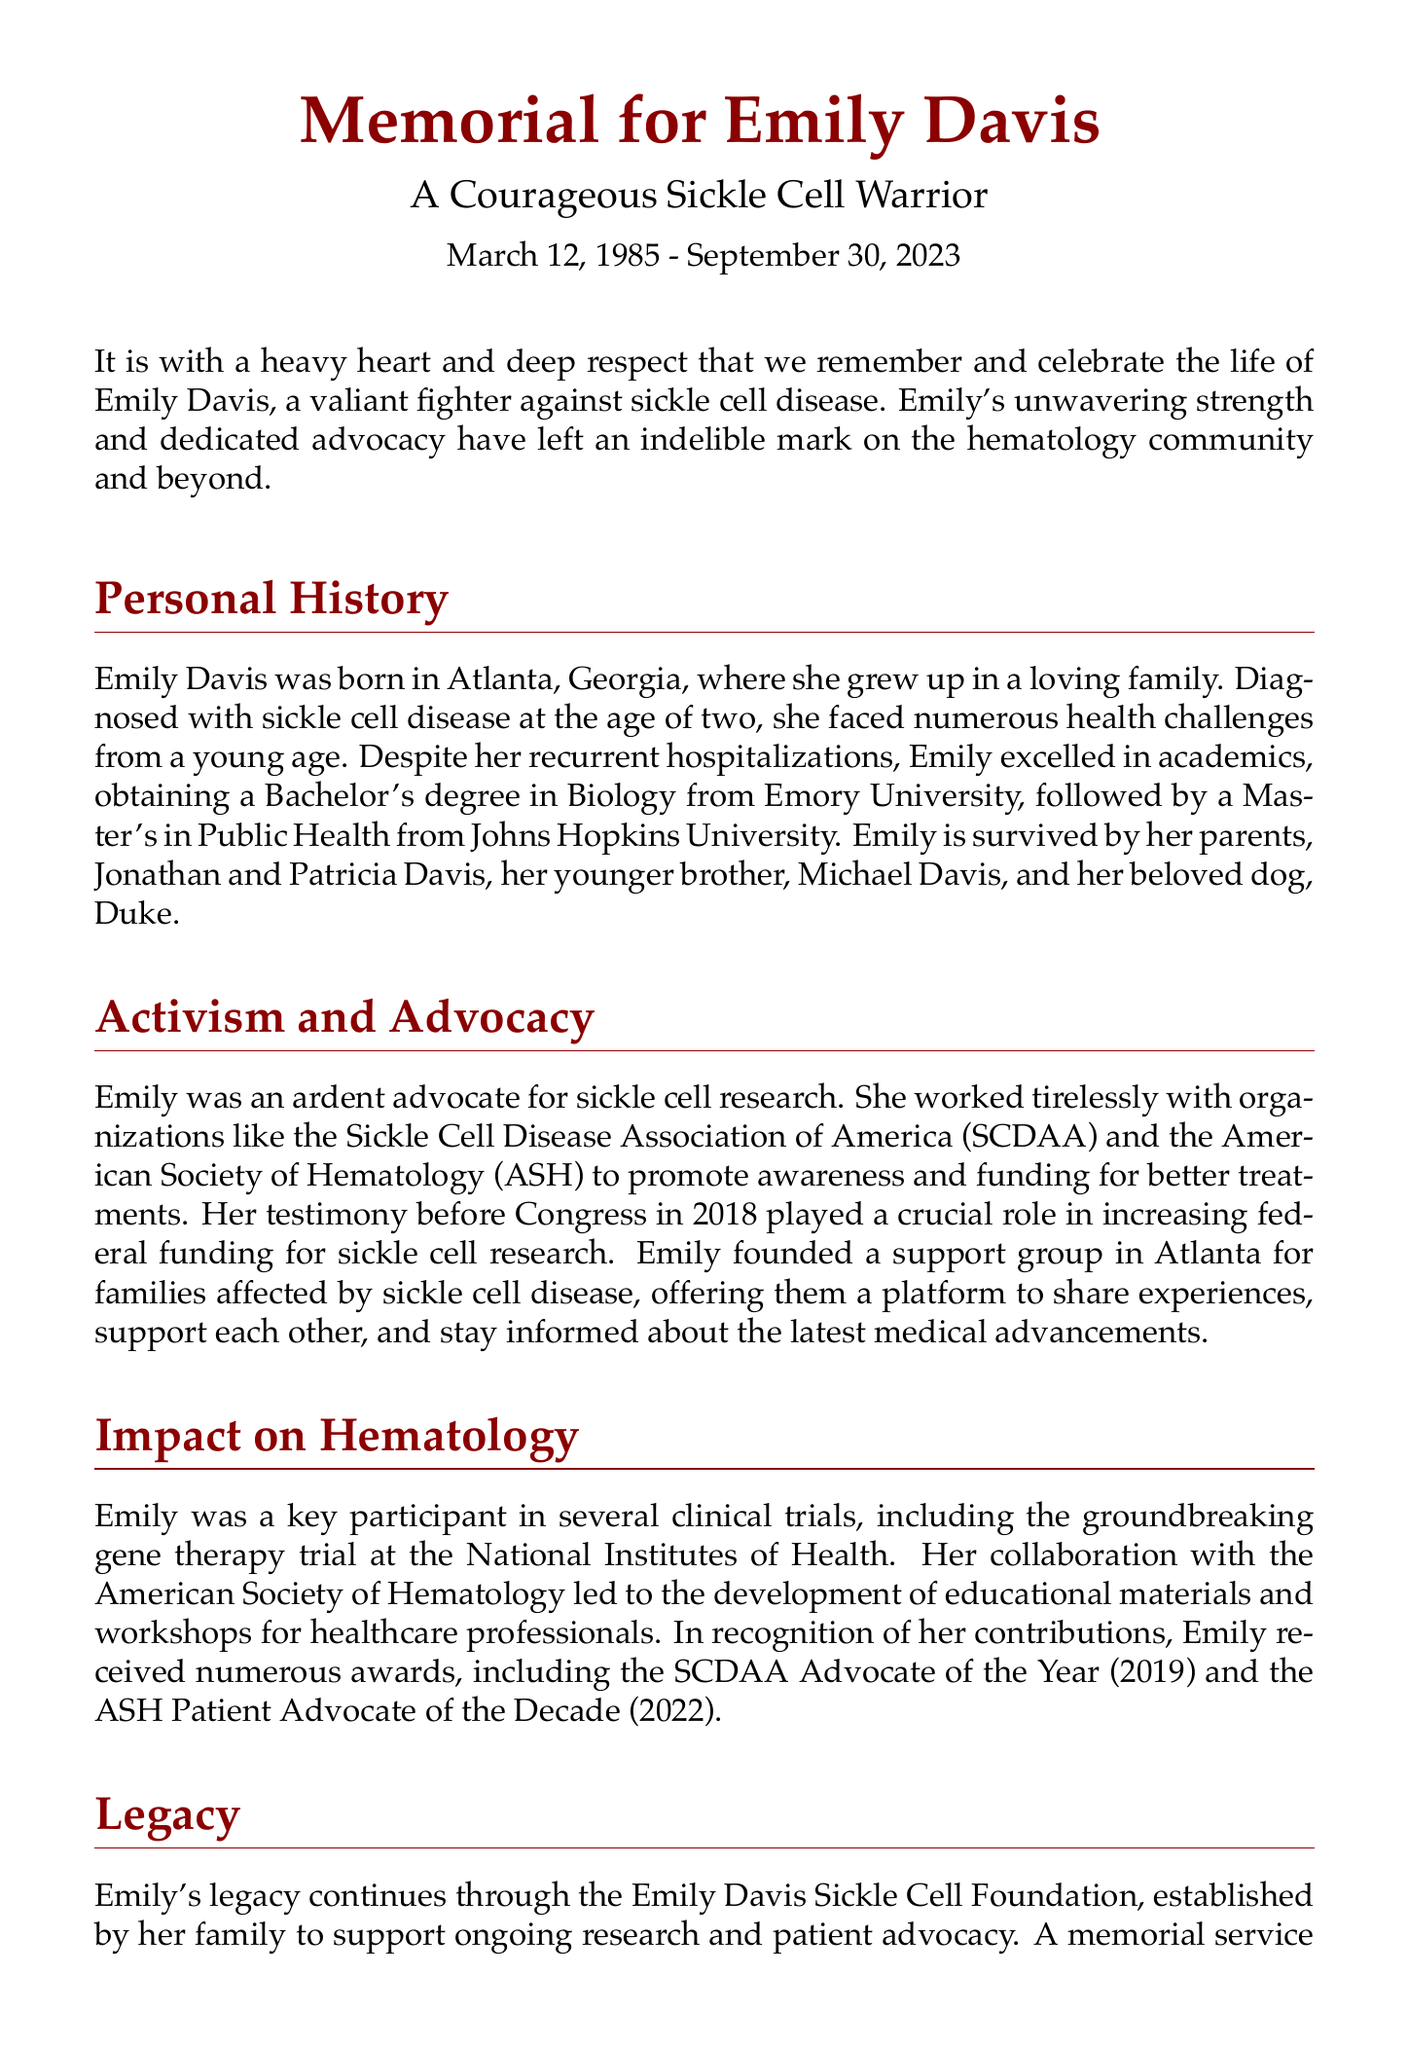What is the birth date of Emily Davis? The document states that Emily Davis was born on March 12, 1985.
Answer: March 12, 1985 What was Emily's academic background? Emily obtained a Bachelor's degree in Biology from Emory University and a Master's in Public Health from Johns Hopkins University.
Answer: Bachelor's degree in Biology, Master's in Public Health Which organizations did Emily work with for advocacy? The document mentions that she worked with the Sickle Cell Disease Association of America (SCDAA) and the American Society of Hematology (ASH).
Answer: SCDAA and ASH When did Emily testify before Congress? According to the document, Emily testified before Congress in 2018.
Answer: 2018 What significant trial did Emily participate in? The document refers to her participation in a groundbreaking gene therapy trial at the National Institutes of Health.
Answer: Gene therapy trial What foundation was established in Emily's memory? The Emily Davis Sickle Cell Foundation was established by her family to support research and advocacy.
Answer: Emily Davis Sickle Cell Foundation What is the date of the memorial service? The memorial service celebrating Emily's life will be held on October 20, 2023.
Answer: October 20, 2023 What accolade did Emily receive in 2022? The document states that she received the ASH Patient Advocate of the Decade in 2022.
Answer: ASH Patient Advocate of the Decade What role did Emily play in the hematology community? Emily's advocacy and contributions significantly impacted the hematology community, especially in sickle cell disease awareness.
Answer: Advocate for sickle cell disease awareness 